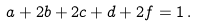<formula> <loc_0><loc_0><loc_500><loc_500>a + 2 b + 2 c + d + 2 f = 1 \, .</formula> 